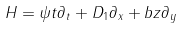Convert formula to latex. <formula><loc_0><loc_0><loc_500><loc_500>H = \psi t \partial _ { t } + D _ { 1 } \partial _ { x } + b z \partial _ { y }</formula> 